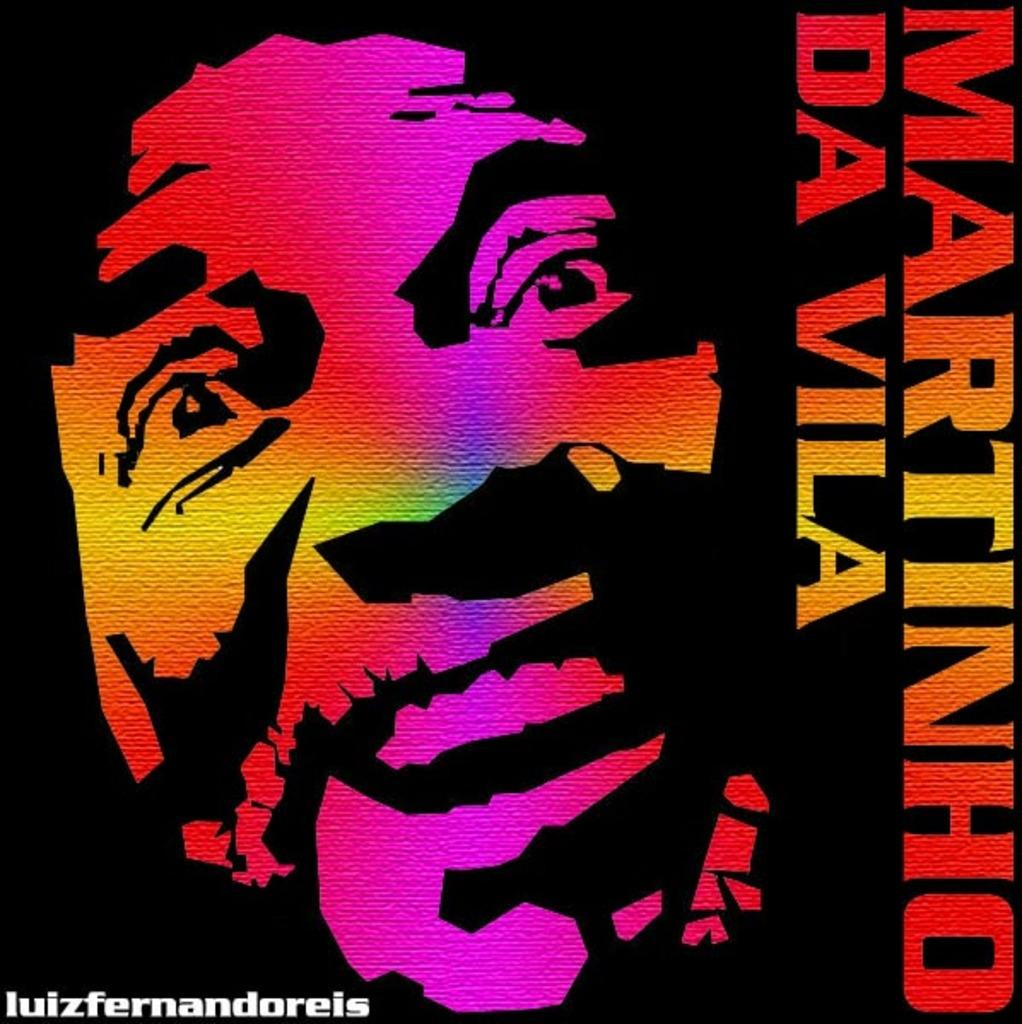What type of image is the main subject of the poster? The main subject of the poster is a painting of a person's face. Where is the text located on the poster? The text is written on the right side of the poster. What can be found in the bottom left corner of the poster? There is a watermark in the left bottom corner of the poster. What type of riddle is depicted in the painting on the poster? There is no riddle depicted in the painting on the poster; it is a portrait of a person's face. How does the drain contribute to the overall design of the poster? There is no drain present in the poster; it is a poster featuring a painting of a person's face with text and a watermark. 